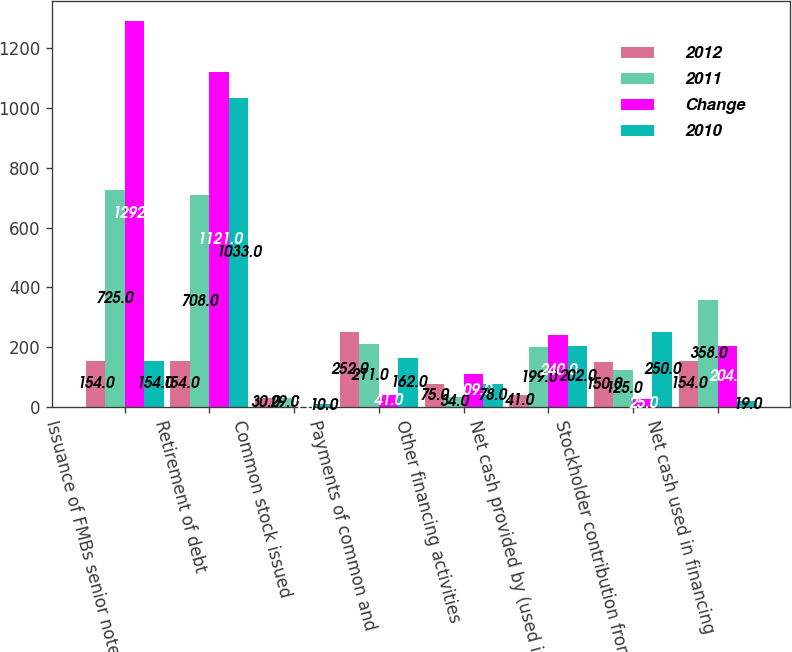Convert chart to OTSL. <chart><loc_0><loc_0><loc_500><loc_500><stacked_bar_chart><ecel><fcel>Issuance of FMBs senior notes<fcel>Retirement of debt<fcel>Common stock issued<fcel>Payments of common and<fcel>Other financing activities<fcel>Net cash provided by (used in)<fcel>Stockholder contribution from<fcel>Net cash used in financing<nl><fcel>2012<fcel>154<fcel>154<fcel>30<fcel>252<fcel>75<fcel>41<fcel>150<fcel>154<nl><fcel>2011<fcel>725<fcel>708<fcel>29<fcel>211<fcel>34<fcel>199<fcel>125<fcel>358<nl><fcel>Change<fcel>1292<fcel>1121<fcel>1<fcel>41<fcel>109<fcel>240<fcel>25<fcel>204<nl><fcel>2010<fcel>154<fcel>1033<fcel>10<fcel>162<fcel>78<fcel>202<fcel>250<fcel>19<nl></chart> 